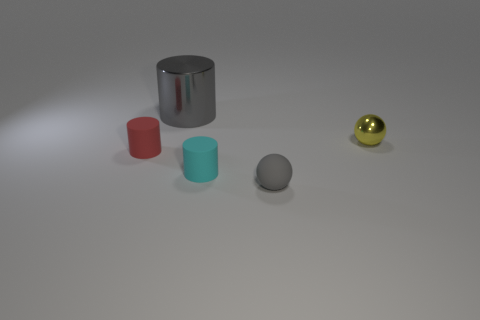There is a tiny cylinder to the right of the gray object on the left side of the tiny gray rubber ball; what color is it?
Ensure brevity in your answer.  Cyan. What number of other objects are there of the same color as the shiny cylinder?
Your answer should be compact. 1. How big is the gray metallic object?
Provide a succinct answer. Large. Are there more small cyan objects to the left of the cyan rubber object than cyan rubber objects on the left side of the yellow metallic object?
Offer a terse response. No. What number of matte things are in front of the small cyan thing to the right of the big thing?
Make the answer very short. 1. There is a small matte object on the right side of the cyan object; does it have the same shape as the small red thing?
Offer a terse response. No. What material is the other thing that is the same shape as the tiny gray thing?
Offer a very short reply. Metal. What number of cyan things have the same size as the red matte object?
Offer a very short reply. 1. What color is the rubber thing that is right of the big object and left of the small gray sphere?
Offer a very short reply. Cyan. Is the number of green metallic blocks less than the number of large things?
Provide a succinct answer. Yes. 